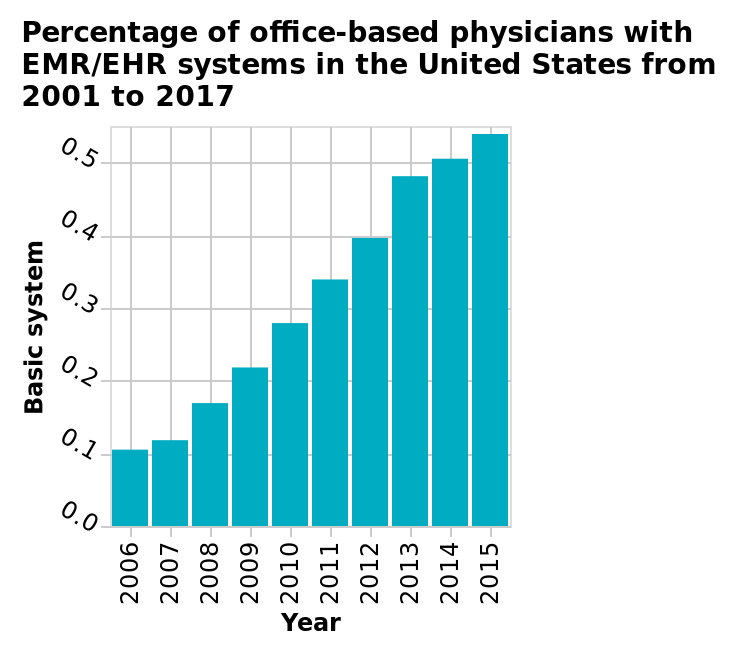<image>
Was there a consistent increase in the percentage of office-based physicians with EMR/EHR systems from 2006 to 2015?  Yes, there was a consistent increase in the percentage of office-based physicians with EMR/EHR systems from 2006 to 2015. How has the percentage of office-based physicians with EMR/EHR systems in the US been changing over the years?  The percentage of office-based physicians with EMR/EHR systems in the US has been increasing gradually year on year. What was the percentage of office-based physicians with EMR/EHR systems in the US in 2006?  The percentage of office-based physicians with EMR/EHR systems in the US in 2006 was just over 0.1. What is shown on the y-axis of the bar graph? On the y-axis of the bar graph, the "Basic system" is defined. 